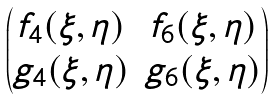Convert formula to latex. <formula><loc_0><loc_0><loc_500><loc_500>\begin{pmatrix} f _ { 4 } ( \xi , \eta ) & f _ { 6 } ( \xi , \eta ) \\ g _ { 4 } ( \xi , \eta ) & g _ { 6 } ( \xi , \eta ) \end{pmatrix}</formula> 